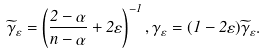<formula> <loc_0><loc_0><loc_500><loc_500>\widetilde { \gamma } _ { \varepsilon } = \left ( \frac { 2 - \alpha } { n - \alpha } + 2 \varepsilon \right ) ^ { - 1 } , \gamma _ { \varepsilon } = ( 1 - 2 \varepsilon ) \widetilde { \gamma } _ { \varepsilon } .</formula> 